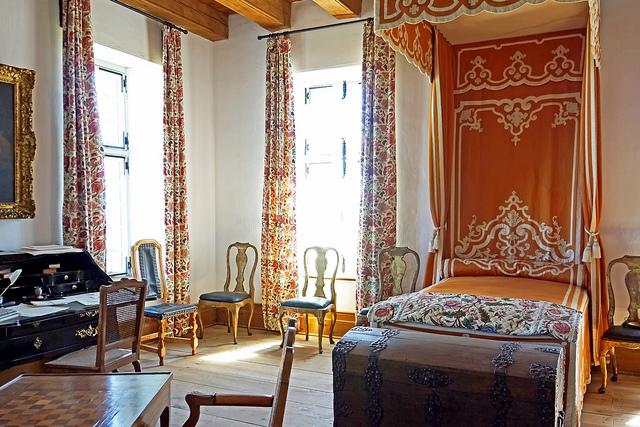What color are the curtains?
Be succinct. Orange and white. Is this room contemporary or traditionally furnished?
Answer briefly. Traditionally. How many chairs are there?
Short answer required. 7. Is that a chest at the end of the bed?
Quick response, please. Yes. 